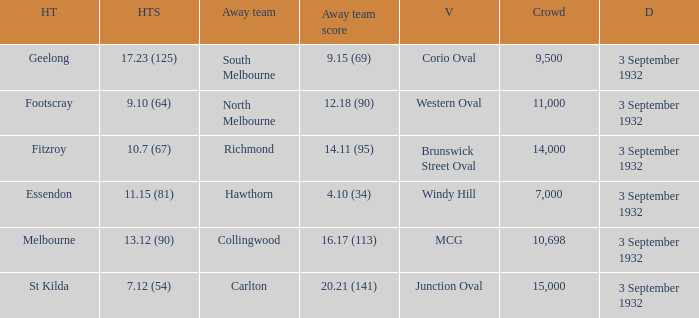What is the Home team score for the Away team of North Melbourne? 9.10 (64). 